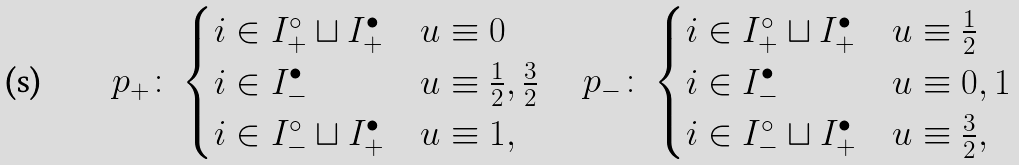Convert formula to latex. <formula><loc_0><loc_0><loc_500><loc_500>p _ { + } \colon & \begin{cases} i \in I ^ { \circ } _ { + } \sqcup I ^ { \bullet } _ { + } & u \equiv 0 \\ i \in I ^ { \bullet } _ { - } & u \equiv \frac { 1 } { 2 } , \frac { 3 } { 2 } \\ i \in I ^ { \circ } _ { - } \sqcup I ^ { \bullet } _ { + } & u \equiv 1 , \end{cases} \quad p _ { - } \colon \begin{cases} i \in I ^ { \circ } _ { + } \sqcup I ^ { \bullet } _ { + } & u \equiv \frac { 1 } { 2 } \\ i \in I ^ { \bullet } _ { - } & u \equiv 0 , 1 \\ i \in I ^ { \circ } _ { - } \sqcup I ^ { \bullet } _ { + } & u \equiv \frac { 3 } { 2 } , \end{cases}</formula> 